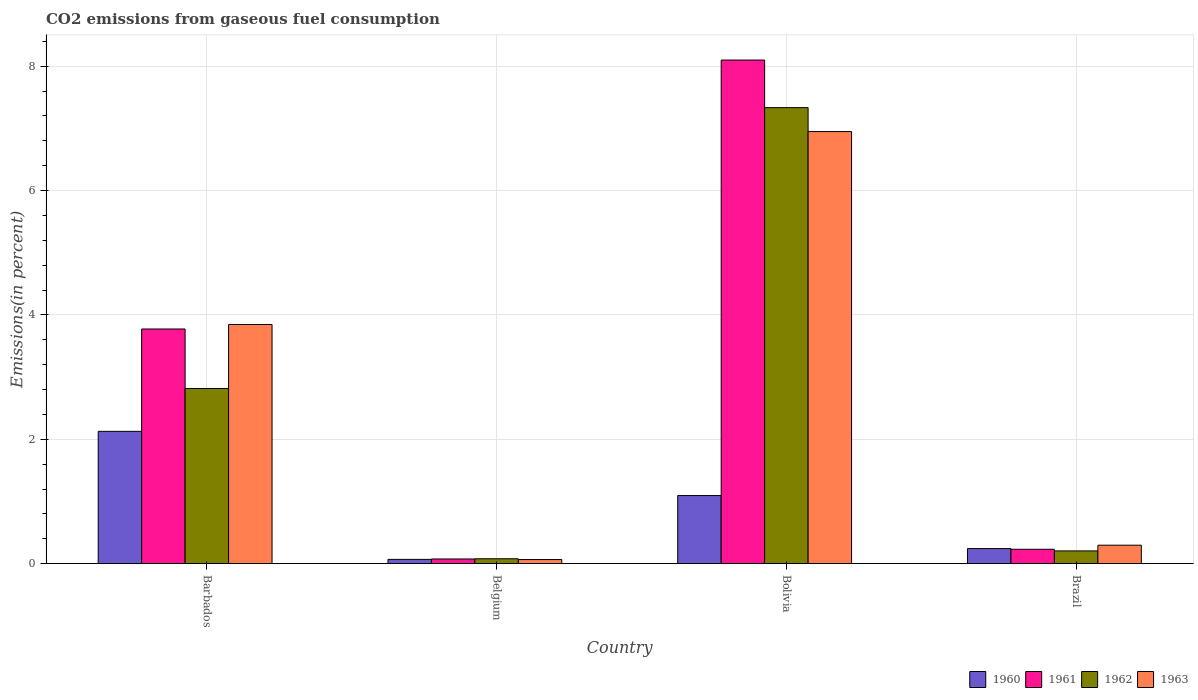How many groups of bars are there?
Provide a succinct answer. 4. How many bars are there on the 3rd tick from the left?
Give a very brief answer. 4. How many bars are there on the 3rd tick from the right?
Make the answer very short. 4. In how many cases, is the number of bars for a given country not equal to the number of legend labels?
Provide a short and direct response. 0. What is the total CO2 emitted in 1960 in Bolivia?
Give a very brief answer. 1.09. Across all countries, what is the maximum total CO2 emitted in 1962?
Make the answer very short. 7.33. Across all countries, what is the minimum total CO2 emitted in 1962?
Keep it short and to the point. 0.08. In which country was the total CO2 emitted in 1961 maximum?
Give a very brief answer. Bolivia. What is the total total CO2 emitted in 1961 in the graph?
Provide a short and direct response. 12.18. What is the difference between the total CO2 emitted in 1961 in Belgium and that in Bolivia?
Make the answer very short. -8.02. What is the difference between the total CO2 emitted in 1962 in Brazil and the total CO2 emitted in 1960 in Barbados?
Provide a succinct answer. -1.92. What is the average total CO2 emitted in 1962 per country?
Keep it short and to the point. 2.61. What is the difference between the total CO2 emitted of/in 1960 and total CO2 emitted of/in 1961 in Belgium?
Make the answer very short. -0.01. In how many countries, is the total CO2 emitted in 1962 greater than 0.8 %?
Provide a succinct answer. 2. What is the ratio of the total CO2 emitted in 1962 in Barbados to that in Belgium?
Provide a short and direct response. 35.89. What is the difference between the highest and the second highest total CO2 emitted in 1960?
Provide a short and direct response. -0.85. What is the difference between the highest and the lowest total CO2 emitted in 1961?
Your answer should be compact. 8.02. In how many countries, is the total CO2 emitted in 1961 greater than the average total CO2 emitted in 1961 taken over all countries?
Offer a very short reply. 2. What does the 3rd bar from the left in Bolivia represents?
Keep it short and to the point. 1962. Is it the case that in every country, the sum of the total CO2 emitted in 1960 and total CO2 emitted in 1961 is greater than the total CO2 emitted in 1962?
Your answer should be very brief. Yes. How many bars are there?
Offer a very short reply. 16. Does the graph contain any zero values?
Give a very brief answer. No. Where does the legend appear in the graph?
Make the answer very short. Bottom right. How many legend labels are there?
Make the answer very short. 4. What is the title of the graph?
Offer a terse response. CO2 emissions from gaseous fuel consumption. What is the label or title of the Y-axis?
Make the answer very short. Emissions(in percent). What is the Emissions(in percent) of 1960 in Barbados?
Your answer should be very brief. 2.13. What is the Emissions(in percent) of 1961 in Barbados?
Offer a very short reply. 3.77. What is the Emissions(in percent) in 1962 in Barbados?
Your response must be concise. 2.82. What is the Emissions(in percent) in 1963 in Barbados?
Make the answer very short. 3.85. What is the Emissions(in percent) of 1960 in Belgium?
Make the answer very short. 0.07. What is the Emissions(in percent) in 1961 in Belgium?
Provide a succinct answer. 0.08. What is the Emissions(in percent) of 1962 in Belgium?
Provide a short and direct response. 0.08. What is the Emissions(in percent) in 1963 in Belgium?
Offer a terse response. 0.07. What is the Emissions(in percent) in 1960 in Bolivia?
Provide a short and direct response. 1.09. What is the Emissions(in percent) of 1961 in Bolivia?
Provide a short and direct response. 8.1. What is the Emissions(in percent) of 1962 in Bolivia?
Offer a very short reply. 7.33. What is the Emissions(in percent) of 1963 in Bolivia?
Keep it short and to the point. 6.95. What is the Emissions(in percent) in 1960 in Brazil?
Provide a succinct answer. 0.24. What is the Emissions(in percent) in 1961 in Brazil?
Make the answer very short. 0.23. What is the Emissions(in percent) in 1962 in Brazil?
Offer a terse response. 0.2. What is the Emissions(in percent) in 1963 in Brazil?
Your answer should be compact. 0.3. Across all countries, what is the maximum Emissions(in percent) of 1960?
Provide a succinct answer. 2.13. Across all countries, what is the maximum Emissions(in percent) in 1961?
Your response must be concise. 8.1. Across all countries, what is the maximum Emissions(in percent) of 1962?
Ensure brevity in your answer.  7.33. Across all countries, what is the maximum Emissions(in percent) of 1963?
Provide a succinct answer. 6.95. Across all countries, what is the minimum Emissions(in percent) in 1960?
Offer a very short reply. 0.07. Across all countries, what is the minimum Emissions(in percent) in 1961?
Your answer should be very brief. 0.08. Across all countries, what is the minimum Emissions(in percent) of 1962?
Make the answer very short. 0.08. Across all countries, what is the minimum Emissions(in percent) of 1963?
Your response must be concise. 0.07. What is the total Emissions(in percent) in 1960 in the graph?
Your answer should be very brief. 3.53. What is the total Emissions(in percent) of 1961 in the graph?
Give a very brief answer. 12.18. What is the total Emissions(in percent) of 1962 in the graph?
Give a very brief answer. 10.43. What is the total Emissions(in percent) in 1963 in the graph?
Your response must be concise. 11.16. What is the difference between the Emissions(in percent) of 1960 in Barbados and that in Belgium?
Offer a terse response. 2.06. What is the difference between the Emissions(in percent) in 1961 in Barbados and that in Belgium?
Make the answer very short. 3.7. What is the difference between the Emissions(in percent) of 1962 in Barbados and that in Belgium?
Ensure brevity in your answer.  2.74. What is the difference between the Emissions(in percent) of 1963 in Barbados and that in Belgium?
Your answer should be compact. 3.78. What is the difference between the Emissions(in percent) in 1960 in Barbados and that in Bolivia?
Ensure brevity in your answer.  1.03. What is the difference between the Emissions(in percent) of 1961 in Barbados and that in Bolivia?
Your answer should be very brief. -4.33. What is the difference between the Emissions(in percent) of 1962 in Barbados and that in Bolivia?
Provide a short and direct response. -4.52. What is the difference between the Emissions(in percent) of 1963 in Barbados and that in Bolivia?
Your answer should be compact. -3.1. What is the difference between the Emissions(in percent) in 1960 in Barbados and that in Brazil?
Your answer should be compact. 1.89. What is the difference between the Emissions(in percent) of 1961 in Barbados and that in Brazil?
Your response must be concise. 3.54. What is the difference between the Emissions(in percent) of 1962 in Barbados and that in Brazil?
Ensure brevity in your answer.  2.61. What is the difference between the Emissions(in percent) in 1963 in Barbados and that in Brazil?
Keep it short and to the point. 3.55. What is the difference between the Emissions(in percent) of 1960 in Belgium and that in Bolivia?
Ensure brevity in your answer.  -1.03. What is the difference between the Emissions(in percent) in 1961 in Belgium and that in Bolivia?
Your response must be concise. -8.02. What is the difference between the Emissions(in percent) of 1962 in Belgium and that in Bolivia?
Your response must be concise. -7.25. What is the difference between the Emissions(in percent) in 1963 in Belgium and that in Bolivia?
Offer a very short reply. -6.88. What is the difference between the Emissions(in percent) of 1960 in Belgium and that in Brazil?
Your response must be concise. -0.17. What is the difference between the Emissions(in percent) in 1961 in Belgium and that in Brazil?
Your response must be concise. -0.16. What is the difference between the Emissions(in percent) in 1962 in Belgium and that in Brazil?
Ensure brevity in your answer.  -0.13. What is the difference between the Emissions(in percent) in 1963 in Belgium and that in Brazil?
Offer a terse response. -0.23. What is the difference between the Emissions(in percent) in 1960 in Bolivia and that in Brazil?
Make the answer very short. 0.85. What is the difference between the Emissions(in percent) of 1961 in Bolivia and that in Brazil?
Give a very brief answer. 7.87. What is the difference between the Emissions(in percent) of 1962 in Bolivia and that in Brazil?
Offer a terse response. 7.13. What is the difference between the Emissions(in percent) of 1963 in Bolivia and that in Brazil?
Keep it short and to the point. 6.65. What is the difference between the Emissions(in percent) of 1960 in Barbados and the Emissions(in percent) of 1961 in Belgium?
Give a very brief answer. 2.05. What is the difference between the Emissions(in percent) in 1960 in Barbados and the Emissions(in percent) in 1962 in Belgium?
Ensure brevity in your answer.  2.05. What is the difference between the Emissions(in percent) of 1960 in Barbados and the Emissions(in percent) of 1963 in Belgium?
Ensure brevity in your answer.  2.06. What is the difference between the Emissions(in percent) of 1961 in Barbados and the Emissions(in percent) of 1962 in Belgium?
Keep it short and to the point. 3.7. What is the difference between the Emissions(in percent) of 1961 in Barbados and the Emissions(in percent) of 1963 in Belgium?
Keep it short and to the point. 3.71. What is the difference between the Emissions(in percent) in 1962 in Barbados and the Emissions(in percent) in 1963 in Belgium?
Offer a very short reply. 2.75. What is the difference between the Emissions(in percent) of 1960 in Barbados and the Emissions(in percent) of 1961 in Bolivia?
Your response must be concise. -5.97. What is the difference between the Emissions(in percent) of 1960 in Barbados and the Emissions(in percent) of 1962 in Bolivia?
Your answer should be compact. -5.21. What is the difference between the Emissions(in percent) in 1960 in Barbados and the Emissions(in percent) in 1963 in Bolivia?
Give a very brief answer. -4.82. What is the difference between the Emissions(in percent) in 1961 in Barbados and the Emissions(in percent) in 1962 in Bolivia?
Make the answer very short. -3.56. What is the difference between the Emissions(in percent) of 1961 in Barbados and the Emissions(in percent) of 1963 in Bolivia?
Provide a short and direct response. -3.18. What is the difference between the Emissions(in percent) of 1962 in Barbados and the Emissions(in percent) of 1963 in Bolivia?
Your answer should be compact. -4.13. What is the difference between the Emissions(in percent) in 1960 in Barbados and the Emissions(in percent) in 1961 in Brazil?
Give a very brief answer. 1.9. What is the difference between the Emissions(in percent) of 1960 in Barbados and the Emissions(in percent) of 1962 in Brazil?
Keep it short and to the point. 1.92. What is the difference between the Emissions(in percent) in 1960 in Barbados and the Emissions(in percent) in 1963 in Brazil?
Give a very brief answer. 1.83. What is the difference between the Emissions(in percent) of 1961 in Barbados and the Emissions(in percent) of 1962 in Brazil?
Provide a short and direct response. 3.57. What is the difference between the Emissions(in percent) of 1961 in Barbados and the Emissions(in percent) of 1963 in Brazil?
Offer a terse response. 3.48. What is the difference between the Emissions(in percent) in 1962 in Barbados and the Emissions(in percent) in 1963 in Brazil?
Make the answer very short. 2.52. What is the difference between the Emissions(in percent) of 1960 in Belgium and the Emissions(in percent) of 1961 in Bolivia?
Your answer should be compact. -8.03. What is the difference between the Emissions(in percent) in 1960 in Belgium and the Emissions(in percent) in 1962 in Bolivia?
Your answer should be very brief. -7.26. What is the difference between the Emissions(in percent) of 1960 in Belgium and the Emissions(in percent) of 1963 in Bolivia?
Provide a succinct answer. -6.88. What is the difference between the Emissions(in percent) in 1961 in Belgium and the Emissions(in percent) in 1962 in Bolivia?
Give a very brief answer. -7.26. What is the difference between the Emissions(in percent) in 1961 in Belgium and the Emissions(in percent) in 1963 in Bolivia?
Provide a succinct answer. -6.87. What is the difference between the Emissions(in percent) in 1962 in Belgium and the Emissions(in percent) in 1963 in Bolivia?
Offer a very short reply. -6.87. What is the difference between the Emissions(in percent) of 1960 in Belgium and the Emissions(in percent) of 1961 in Brazil?
Ensure brevity in your answer.  -0.16. What is the difference between the Emissions(in percent) in 1960 in Belgium and the Emissions(in percent) in 1962 in Brazil?
Keep it short and to the point. -0.14. What is the difference between the Emissions(in percent) in 1960 in Belgium and the Emissions(in percent) in 1963 in Brazil?
Provide a succinct answer. -0.23. What is the difference between the Emissions(in percent) in 1961 in Belgium and the Emissions(in percent) in 1962 in Brazil?
Your response must be concise. -0.13. What is the difference between the Emissions(in percent) in 1961 in Belgium and the Emissions(in percent) in 1963 in Brazil?
Keep it short and to the point. -0.22. What is the difference between the Emissions(in percent) in 1962 in Belgium and the Emissions(in percent) in 1963 in Brazil?
Your response must be concise. -0.22. What is the difference between the Emissions(in percent) of 1960 in Bolivia and the Emissions(in percent) of 1961 in Brazil?
Keep it short and to the point. 0.86. What is the difference between the Emissions(in percent) in 1960 in Bolivia and the Emissions(in percent) in 1962 in Brazil?
Provide a succinct answer. 0.89. What is the difference between the Emissions(in percent) of 1960 in Bolivia and the Emissions(in percent) of 1963 in Brazil?
Keep it short and to the point. 0.8. What is the difference between the Emissions(in percent) of 1961 in Bolivia and the Emissions(in percent) of 1962 in Brazil?
Ensure brevity in your answer.  7.89. What is the difference between the Emissions(in percent) in 1961 in Bolivia and the Emissions(in percent) in 1963 in Brazil?
Provide a succinct answer. 7.8. What is the difference between the Emissions(in percent) of 1962 in Bolivia and the Emissions(in percent) of 1963 in Brazil?
Offer a very short reply. 7.04. What is the average Emissions(in percent) in 1960 per country?
Provide a short and direct response. 0.88. What is the average Emissions(in percent) of 1961 per country?
Provide a short and direct response. 3.04. What is the average Emissions(in percent) in 1962 per country?
Give a very brief answer. 2.61. What is the average Emissions(in percent) in 1963 per country?
Your answer should be compact. 2.79. What is the difference between the Emissions(in percent) of 1960 and Emissions(in percent) of 1961 in Barbados?
Keep it short and to the point. -1.65. What is the difference between the Emissions(in percent) in 1960 and Emissions(in percent) in 1962 in Barbados?
Offer a terse response. -0.69. What is the difference between the Emissions(in percent) in 1960 and Emissions(in percent) in 1963 in Barbados?
Provide a succinct answer. -1.72. What is the difference between the Emissions(in percent) in 1961 and Emissions(in percent) in 1962 in Barbados?
Offer a terse response. 0.96. What is the difference between the Emissions(in percent) in 1961 and Emissions(in percent) in 1963 in Barbados?
Provide a short and direct response. -0.07. What is the difference between the Emissions(in percent) in 1962 and Emissions(in percent) in 1963 in Barbados?
Your response must be concise. -1.03. What is the difference between the Emissions(in percent) in 1960 and Emissions(in percent) in 1961 in Belgium?
Offer a terse response. -0.01. What is the difference between the Emissions(in percent) of 1960 and Emissions(in percent) of 1962 in Belgium?
Your answer should be compact. -0.01. What is the difference between the Emissions(in percent) in 1960 and Emissions(in percent) in 1963 in Belgium?
Your answer should be compact. 0. What is the difference between the Emissions(in percent) in 1961 and Emissions(in percent) in 1962 in Belgium?
Keep it short and to the point. -0. What is the difference between the Emissions(in percent) of 1961 and Emissions(in percent) of 1963 in Belgium?
Your response must be concise. 0.01. What is the difference between the Emissions(in percent) of 1962 and Emissions(in percent) of 1963 in Belgium?
Your answer should be very brief. 0.01. What is the difference between the Emissions(in percent) in 1960 and Emissions(in percent) in 1961 in Bolivia?
Give a very brief answer. -7. What is the difference between the Emissions(in percent) in 1960 and Emissions(in percent) in 1962 in Bolivia?
Your answer should be compact. -6.24. What is the difference between the Emissions(in percent) of 1960 and Emissions(in percent) of 1963 in Bolivia?
Ensure brevity in your answer.  -5.85. What is the difference between the Emissions(in percent) of 1961 and Emissions(in percent) of 1962 in Bolivia?
Make the answer very short. 0.77. What is the difference between the Emissions(in percent) in 1961 and Emissions(in percent) in 1963 in Bolivia?
Keep it short and to the point. 1.15. What is the difference between the Emissions(in percent) of 1962 and Emissions(in percent) of 1963 in Bolivia?
Provide a short and direct response. 0.38. What is the difference between the Emissions(in percent) of 1960 and Emissions(in percent) of 1961 in Brazil?
Offer a terse response. 0.01. What is the difference between the Emissions(in percent) in 1960 and Emissions(in percent) in 1962 in Brazil?
Offer a very short reply. 0.04. What is the difference between the Emissions(in percent) of 1960 and Emissions(in percent) of 1963 in Brazil?
Provide a succinct answer. -0.05. What is the difference between the Emissions(in percent) of 1961 and Emissions(in percent) of 1962 in Brazil?
Your answer should be very brief. 0.03. What is the difference between the Emissions(in percent) of 1961 and Emissions(in percent) of 1963 in Brazil?
Offer a terse response. -0.07. What is the difference between the Emissions(in percent) of 1962 and Emissions(in percent) of 1963 in Brazil?
Keep it short and to the point. -0.09. What is the ratio of the Emissions(in percent) of 1960 in Barbados to that in Belgium?
Give a very brief answer. 31.06. What is the ratio of the Emissions(in percent) of 1961 in Barbados to that in Belgium?
Keep it short and to the point. 50.26. What is the ratio of the Emissions(in percent) in 1962 in Barbados to that in Belgium?
Provide a succinct answer. 35.89. What is the ratio of the Emissions(in percent) of 1963 in Barbados to that in Belgium?
Give a very brief answer. 58.39. What is the ratio of the Emissions(in percent) in 1960 in Barbados to that in Bolivia?
Make the answer very short. 1.94. What is the ratio of the Emissions(in percent) in 1961 in Barbados to that in Bolivia?
Your response must be concise. 0.47. What is the ratio of the Emissions(in percent) in 1962 in Barbados to that in Bolivia?
Make the answer very short. 0.38. What is the ratio of the Emissions(in percent) in 1963 in Barbados to that in Bolivia?
Make the answer very short. 0.55. What is the ratio of the Emissions(in percent) in 1960 in Barbados to that in Brazil?
Make the answer very short. 8.78. What is the ratio of the Emissions(in percent) of 1961 in Barbados to that in Brazil?
Offer a terse response. 16.33. What is the ratio of the Emissions(in percent) in 1962 in Barbados to that in Brazil?
Make the answer very short. 13.75. What is the ratio of the Emissions(in percent) of 1963 in Barbados to that in Brazil?
Your response must be concise. 12.96. What is the ratio of the Emissions(in percent) of 1960 in Belgium to that in Bolivia?
Offer a very short reply. 0.06. What is the ratio of the Emissions(in percent) of 1961 in Belgium to that in Bolivia?
Offer a terse response. 0.01. What is the ratio of the Emissions(in percent) of 1962 in Belgium to that in Bolivia?
Keep it short and to the point. 0.01. What is the ratio of the Emissions(in percent) of 1963 in Belgium to that in Bolivia?
Provide a succinct answer. 0.01. What is the ratio of the Emissions(in percent) of 1960 in Belgium to that in Brazil?
Make the answer very short. 0.28. What is the ratio of the Emissions(in percent) of 1961 in Belgium to that in Brazil?
Offer a very short reply. 0.33. What is the ratio of the Emissions(in percent) in 1962 in Belgium to that in Brazil?
Offer a terse response. 0.38. What is the ratio of the Emissions(in percent) in 1963 in Belgium to that in Brazil?
Make the answer very short. 0.22. What is the ratio of the Emissions(in percent) of 1960 in Bolivia to that in Brazil?
Give a very brief answer. 4.52. What is the ratio of the Emissions(in percent) of 1961 in Bolivia to that in Brazil?
Make the answer very short. 35.05. What is the ratio of the Emissions(in percent) in 1962 in Bolivia to that in Brazil?
Offer a terse response. 35.79. What is the ratio of the Emissions(in percent) of 1963 in Bolivia to that in Brazil?
Keep it short and to the point. 23.42. What is the difference between the highest and the second highest Emissions(in percent) in 1960?
Give a very brief answer. 1.03. What is the difference between the highest and the second highest Emissions(in percent) in 1961?
Give a very brief answer. 4.33. What is the difference between the highest and the second highest Emissions(in percent) in 1962?
Your response must be concise. 4.52. What is the difference between the highest and the second highest Emissions(in percent) in 1963?
Keep it short and to the point. 3.1. What is the difference between the highest and the lowest Emissions(in percent) of 1960?
Ensure brevity in your answer.  2.06. What is the difference between the highest and the lowest Emissions(in percent) of 1961?
Make the answer very short. 8.02. What is the difference between the highest and the lowest Emissions(in percent) of 1962?
Provide a succinct answer. 7.25. What is the difference between the highest and the lowest Emissions(in percent) of 1963?
Provide a succinct answer. 6.88. 